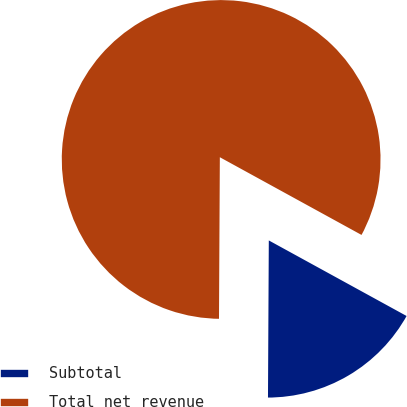<chart> <loc_0><loc_0><loc_500><loc_500><pie_chart><fcel>Subtotal<fcel>Total net revenue<nl><fcel>17.1%<fcel>82.9%<nl></chart> 